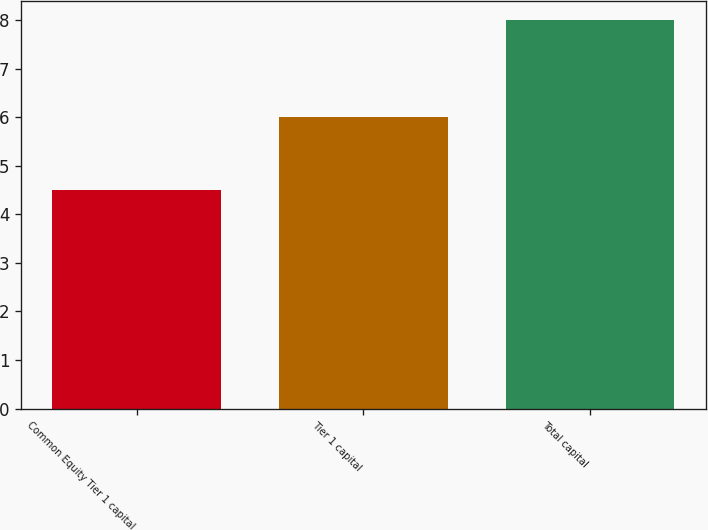Convert chart. <chart><loc_0><loc_0><loc_500><loc_500><bar_chart><fcel>Common Equity Tier 1 capital<fcel>Tier 1 capital<fcel>Total capital<nl><fcel>4.5<fcel>6<fcel>8<nl></chart> 